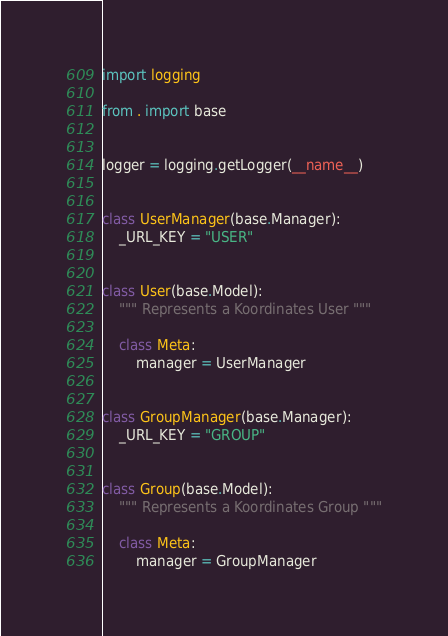<code> <loc_0><loc_0><loc_500><loc_500><_Python_>import logging

from . import base


logger = logging.getLogger(__name__)


class UserManager(base.Manager):
    _URL_KEY = "USER"


class User(base.Model):
    """ Represents a Koordinates User """

    class Meta:
        manager = UserManager


class GroupManager(base.Manager):
    _URL_KEY = "GROUP"


class Group(base.Model):
    """ Represents a Koordinates Group """

    class Meta:
        manager = GroupManager
</code> 